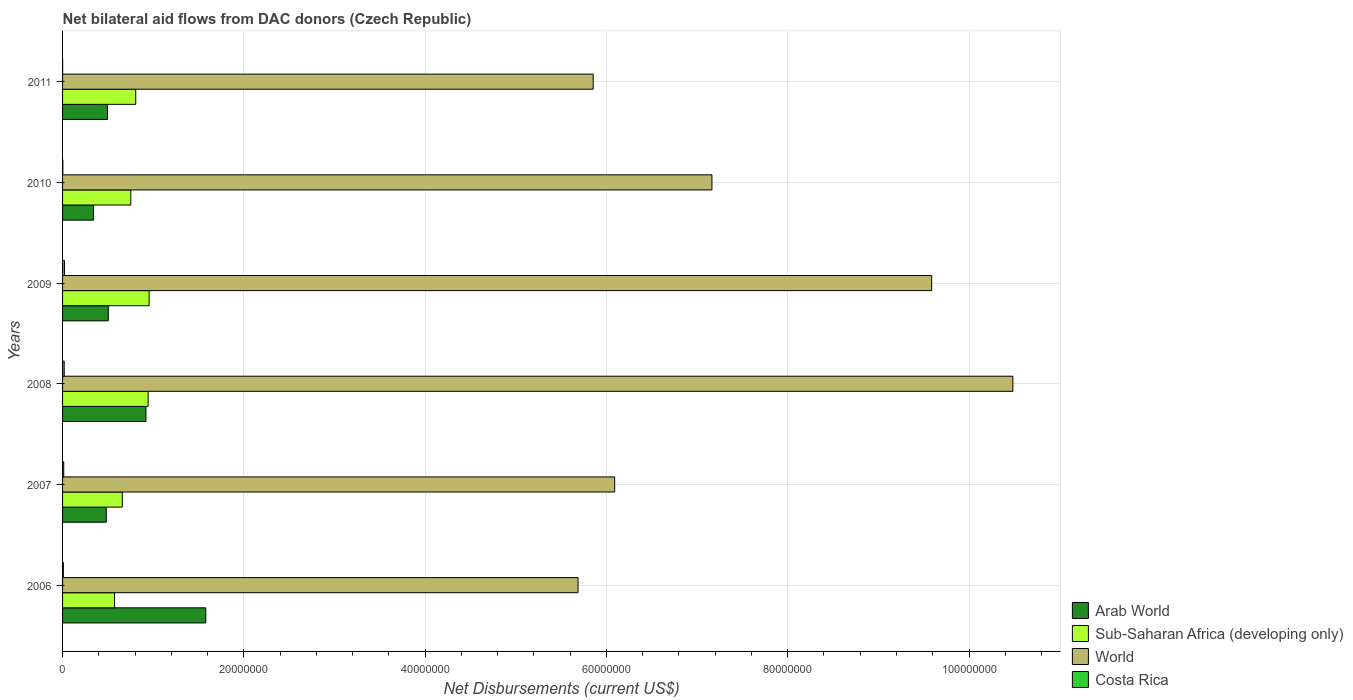How many bars are there on the 1st tick from the bottom?
Provide a short and direct response. 4. What is the label of the 6th group of bars from the top?
Your response must be concise. 2006. In how many cases, is the number of bars for a given year not equal to the number of legend labels?
Give a very brief answer. 0. Across all years, what is the maximum net bilateral aid flows in World?
Give a very brief answer. 1.05e+08. Across all years, what is the minimum net bilateral aid flows in Sub-Saharan Africa (developing only)?
Provide a short and direct response. 5.74e+06. In which year was the net bilateral aid flows in Arab World maximum?
Your response must be concise. 2006. What is the total net bilateral aid flows in Costa Rica in the graph?
Give a very brief answer. 6.50e+05. What is the difference between the net bilateral aid flows in Costa Rica in 2010 and the net bilateral aid flows in Sub-Saharan Africa (developing only) in 2007?
Offer a terse response. -6.56e+06. What is the average net bilateral aid flows in Arab World per year?
Provide a succinct answer. 7.21e+06. In the year 2009, what is the difference between the net bilateral aid flows in Arab World and net bilateral aid flows in Sub-Saharan Africa (developing only)?
Your response must be concise. -4.50e+06. In how many years, is the net bilateral aid flows in Costa Rica greater than 100000000 US$?
Provide a succinct answer. 0. What is the ratio of the net bilateral aid flows in World in 2007 to that in 2008?
Ensure brevity in your answer.  0.58. Is the net bilateral aid flows in Sub-Saharan Africa (developing only) in 2006 less than that in 2007?
Give a very brief answer. Yes. What is the difference between the highest and the lowest net bilateral aid flows in World?
Your answer should be very brief. 4.80e+07. In how many years, is the net bilateral aid flows in Sub-Saharan Africa (developing only) greater than the average net bilateral aid flows in Sub-Saharan Africa (developing only) taken over all years?
Keep it short and to the point. 3. Is the sum of the net bilateral aid flows in World in 2006 and 2011 greater than the maximum net bilateral aid flows in Sub-Saharan Africa (developing only) across all years?
Keep it short and to the point. Yes. What does the 3rd bar from the top in 2006 represents?
Ensure brevity in your answer.  Sub-Saharan Africa (developing only). What does the 3rd bar from the bottom in 2007 represents?
Make the answer very short. World. Is it the case that in every year, the sum of the net bilateral aid flows in Costa Rica and net bilateral aid flows in Sub-Saharan Africa (developing only) is greater than the net bilateral aid flows in Arab World?
Your answer should be compact. No. Are all the bars in the graph horizontal?
Offer a terse response. Yes. How many years are there in the graph?
Your response must be concise. 6. What is the difference between two consecutive major ticks on the X-axis?
Provide a short and direct response. 2.00e+07. Does the graph contain grids?
Your response must be concise. Yes. What is the title of the graph?
Your answer should be very brief. Net bilateral aid flows from DAC donors (Czech Republic). What is the label or title of the X-axis?
Your answer should be very brief. Net Disbursements (current US$). What is the Net Disbursements (current US$) in Arab World in 2006?
Give a very brief answer. 1.58e+07. What is the Net Disbursements (current US$) of Sub-Saharan Africa (developing only) in 2006?
Your response must be concise. 5.74e+06. What is the Net Disbursements (current US$) of World in 2006?
Offer a terse response. 5.69e+07. What is the Net Disbursements (current US$) in Arab World in 2007?
Provide a succinct answer. 4.82e+06. What is the Net Disbursements (current US$) in Sub-Saharan Africa (developing only) in 2007?
Offer a very short reply. 6.59e+06. What is the Net Disbursements (current US$) of World in 2007?
Your response must be concise. 6.09e+07. What is the Net Disbursements (current US$) in Costa Rica in 2007?
Give a very brief answer. 1.30e+05. What is the Net Disbursements (current US$) of Arab World in 2008?
Ensure brevity in your answer.  9.20e+06. What is the Net Disbursements (current US$) of Sub-Saharan Africa (developing only) in 2008?
Give a very brief answer. 9.44e+06. What is the Net Disbursements (current US$) of World in 2008?
Give a very brief answer. 1.05e+08. What is the Net Disbursements (current US$) in Costa Rica in 2008?
Your answer should be very brief. 1.80e+05. What is the Net Disbursements (current US$) of Arab World in 2009?
Ensure brevity in your answer.  5.05e+06. What is the Net Disbursements (current US$) in Sub-Saharan Africa (developing only) in 2009?
Make the answer very short. 9.55e+06. What is the Net Disbursements (current US$) in World in 2009?
Make the answer very short. 9.59e+07. What is the Net Disbursements (current US$) of Costa Rica in 2009?
Provide a succinct answer. 2.10e+05. What is the Net Disbursements (current US$) of Arab World in 2010?
Offer a very short reply. 3.42e+06. What is the Net Disbursements (current US$) in Sub-Saharan Africa (developing only) in 2010?
Make the answer very short. 7.53e+06. What is the Net Disbursements (current US$) of World in 2010?
Make the answer very short. 7.16e+07. What is the Net Disbursements (current US$) of Costa Rica in 2010?
Provide a succinct answer. 3.00e+04. What is the Net Disbursements (current US$) in Arab World in 2011?
Make the answer very short. 4.95e+06. What is the Net Disbursements (current US$) in Sub-Saharan Africa (developing only) in 2011?
Provide a succinct answer. 8.07e+06. What is the Net Disbursements (current US$) in World in 2011?
Ensure brevity in your answer.  5.85e+07. Across all years, what is the maximum Net Disbursements (current US$) in Arab World?
Your answer should be very brief. 1.58e+07. Across all years, what is the maximum Net Disbursements (current US$) of Sub-Saharan Africa (developing only)?
Your answer should be compact. 9.55e+06. Across all years, what is the maximum Net Disbursements (current US$) of World?
Provide a succinct answer. 1.05e+08. Across all years, what is the maximum Net Disbursements (current US$) in Costa Rica?
Your response must be concise. 2.10e+05. Across all years, what is the minimum Net Disbursements (current US$) of Arab World?
Your response must be concise. 3.42e+06. Across all years, what is the minimum Net Disbursements (current US$) of Sub-Saharan Africa (developing only)?
Give a very brief answer. 5.74e+06. Across all years, what is the minimum Net Disbursements (current US$) of World?
Make the answer very short. 5.69e+07. What is the total Net Disbursements (current US$) of Arab World in the graph?
Your response must be concise. 4.32e+07. What is the total Net Disbursements (current US$) of Sub-Saharan Africa (developing only) in the graph?
Your answer should be very brief. 4.69e+07. What is the total Net Disbursements (current US$) in World in the graph?
Ensure brevity in your answer.  4.49e+08. What is the total Net Disbursements (current US$) in Costa Rica in the graph?
Offer a very short reply. 6.50e+05. What is the difference between the Net Disbursements (current US$) of Arab World in 2006 and that in 2007?
Provide a succinct answer. 1.10e+07. What is the difference between the Net Disbursements (current US$) in Sub-Saharan Africa (developing only) in 2006 and that in 2007?
Provide a succinct answer. -8.50e+05. What is the difference between the Net Disbursements (current US$) of World in 2006 and that in 2007?
Your answer should be very brief. -4.04e+06. What is the difference between the Net Disbursements (current US$) of Arab World in 2006 and that in 2008?
Offer a very short reply. 6.60e+06. What is the difference between the Net Disbursements (current US$) of Sub-Saharan Africa (developing only) in 2006 and that in 2008?
Provide a short and direct response. -3.70e+06. What is the difference between the Net Disbursements (current US$) in World in 2006 and that in 2008?
Offer a very short reply. -4.80e+07. What is the difference between the Net Disbursements (current US$) in Arab World in 2006 and that in 2009?
Provide a succinct answer. 1.08e+07. What is the difference between the Net Disbursements (current US$) of Sub-Saharan Africa (developing only) in 2006 and that in 2009?
Ensure brevity in your answer.  -3.81e+06. What is the difference between the Net Disbursements (current US$) of World in 2006 and that in 2009?
Offer a very short reply. -3.90e+07. What is the difference between the Net Disbursements (current US$) of Arab World in 2006 and that in 2010?
Your response must be concise. 1.24e+07. What is the difference between the Net Disbursements (current US$) in Sub-Saharan Africa (developing only) in 2006 and that in 2010?
Provide a short and direct response. -1.79e+06. What is the difference between the Net Disbursements (current US$) of World in 2006 and that in 2010?
Provide a succinct answer. -1.48e+07. What is the difference between the Net Disbursements (current US$) of Costa Rica in 2006 and that in 2010?
Keep it short and to the point. 6.00e+04. What is the difference between the Net Disbursements (current US$) in Arab World in 2006 and that in 2011?
Provide a succinct answer. 1.08e+07. What is the difference between the Net Disbursements (current US$) in Sub-Saharan Africa (developing only) in 2006 and that in 2011?
Give a very brief answer. -2.33e+06. What is the difference between the Net Disbursements (current US$) in World in 2006 and that in 2011?
Provide a succinct answer. -1.67e+06. What is the difference between the Net Disbursements (current US$) in Arab World in 2007 and that in 2008?
Your response must be concise. -4.38e+06. What is the difference between the Net Disbursements (current US$) in Sub-Saharan Africa (developing only) in 2007 and that in 2008?
Provide a succinct answer. -2.85e+06. What is the difference between the Net Disbursements (current US$) in World in 2007 and that in 2008?
Ensure brevity in your answer.  -4.39e+07. What is the difference between the Net Disbursements (current US$) in Sub-Saharan Africa (developing only) in 2007 and that in 2009?
Give a very brief answer. -2.96e+06. What is the difference between the Net Disbursements (current US$) in World in 2007 and that in 2009?
Your answer should be compact. -3.50e+07. What is the difference between the Net Disbursements (current US$) in Arab World in 2007 and that in 2010?
Offer a terse response. 1.40e+06. What is the difference between the Net Disbursements (current US$) in Sub-Saharan Africa (developing only) in 2007 and that in 2010?
Give a very brief answer. -9.40e+05. What is the difference between the Net Disbursements (current US$) of World in 2007 and that in 2010?
Ensure brevity in your answer.  -1.07e+07. What is the difference between the Net Disbursements (current US$) in Sub-Saharan Africa (developing only) in 2007 and that in 2011?
Your answer should be very brief. -1.48e+06. What is the difference between the Net Disbursements (current US$) of World in 2007 and that in 2011?
Provide a short and direct response. 2.37e+06. What is the difference between the Net Disbursements (current US$) of Costa Rica in 2007 and that in 2011?
Keep it short and to the point. 1.20e+05. What is the difference between the Net Disbursements (current US$) in Arab World in 2008 and that in 2009?
Ensure brevity in your answer.  4.15e+06. What is the difference between the Net Disbursements (current US$) of World in 2008 and that in 2009?
Provide a succinct answer. 8.96e+06. What is the difference between the Net Disbursements (current US$) of Arab World in 2008 and that in 2010?
Provide a succinct answer. 5.78e+06. What is the difference between the Net Disbursements (current US$) in Sub-Saharan Africa (developing only) in 2008 and that in 2010?
Give a very brief answer. 1.91e+06. What is the difference between the Net Disbursements (current US$) in World in 2008 and that in 2010?
Give a very brief answer. 3.32e+07. What is the difference between the Net Disbursements (current US$) in Arab World in 2008 and that in 2011?
Give a very brief answer. 4.25e+06. What is the difference between the Net Disbursements (current US$) of Sub-Saharan Africa (developing only) in 2008 and that in 2011?
Give a very brief answer. 1.37e+06. What is the difference between the Net Disbursements (current US$) of World in 2008 and that in 2011?
Provide a succinct answer. 4.63e+07. What is the difference between the Net Disbursements (current US$) of Arab World in 2009 and that in 2010?
Provide a succinct answer. 1.63e+06. What is the difference between the Net Disbursements (current US$) in Sub-Saharan Africa (developing only) in 2009 and that in 2010?
Offer a terse response. 2.02e+06. What is the difference between the Net Disbursements (current US$) in World in 2009 and that in 2010?
Your answer should be compact. 2.42e+07. What is the difference between the Net Disbursements (current US$) in Costa Rica in 2009 and that in 2010?
Offer a very short reply. 1.80e+05. What is the difference between the Net Disbursements (current US$) of Arab World in 2009 and that in 2011?
Offer a very short reply. 1.00e+05. What is the difference between the Net Disbursements (current US$) of Sub-Saharan Africa (developing only) in 2009 and that in 2011?
Provide a short and direct response. 1.48e+06. What is the difference between the Net Disbursements (current US$) of World in 2009 and that in 2011?
Ensure brevity in your answer.  3.73e+07. What is the difference between the Net Disbursements (current US$) in Costa Rica in 2009 and that in 2011?
Keep it short and to the point. 2.00e+05. What is the difference between the Net Disbursements (current US$) of Arab World in 2010 and that in 2011?
Your answer should be compact. -1.53e+06. What is the difference between the Net Disbursements (current US$) of Sub-Saharan Africa (developing only) in 2010 and that in 2011?
Keep it short and to the point. -5.40e+05. What is the difference between the Net Disbursements (current US$) in World in 2010 and that in 2011?
Offer a very short reply. 1.31e+07. What is the difference between the Net Disbursements (current US$) of Costa Rica in 2010 and that in 2011?
Offer a terse response. 2.00e+04. What is the difference between the Net Disbursements (current US$) in Arab World in 2006 and the Net Disbursements (current US$) in Sub-Saharan Africa (developing only) in 2007?
Make the answer very short. 9.21e+06. What is the difference between the Net Disbursements (current US$) in Arab World in 2006 and the Net Disbursements (current US$) in World in 2007?
Make the answer very short. -4.51e+07. What is the difference between the Net Disbursements (current US$) of Arab World in 2006 and the Net Disbursements (current US$) of Costa Rica in 2007?
Provide a succinct answer. 1.57e+07. What is the difference between the Net Disbursements (current US$) of Sub-Saharan Africa (developing only) in 2006 and the Net Disbursements (current US$) of World in 2007?
Provide a succinct answer. -5.52e+07. What is the difference between the Net Disbursements (current US$) of Sub-Saharan Africa (developing only) in 2006 and the Net Disbursements (current US$) of Costa Rica in 2007?
Your response must be concise. 5.61e+06. What is the difference between the Net Disbursements (current US$) in World in 2006 and the Net Disbursements (current US$) in Costa Rica in 2007?
Make the answer very short. 5.67e+07. What is the difference between the Net Disbursements (current US$) of Arab World in 2006 and the Net Disbursements (current US$) of Sub-Saharan Africa (developing only) in 2008?
Your answer should be compact. 6.36e+06. What is the difference between the Net Disbursements (current US$) of Arab World in 2006 and the Net Disbursements (current US$) of World in 2008?
Make the answer very short. -8.90e+07. What is the difference between the Net Disbursements (current US$) of Arab World in 2006 and the Net Disbursements (current US$) of Costa Rica in 2008?
Your answer should be very brief. 1.56e+07. What is the difference between the Net Disbursements (current US$) of Sub-Saharan Africa (developing only) in 2006 and the Net Disbursements (current US$) of World in 2008?
Provide a succinct answer. -9.91e+07. What is the difference between the Net Disbursements (current US$) of Sub-Saharan Africa (developing only) in 2006 and the Net Disbursements (current US$) of Costa Rica in 2008?
Keep it short and to the point. 5.56e+06. What is the difference between the Net Disbursements (current US$) in World in 2006 and the Net Disbursements (current US$) in Costa Rica in 2008?
Keep it short and to the point. 5.67e+07. What is the difference between the Net Disbursements (current US$) in Arab World in 2006 and the Net Disbursements (current US$) in Sub-Saharan Africa (developing only) in 2009?
Make the answer very short. 6.25e+06. What is the difference between the Net Disbursements (current US$) of Arab World in 2006 and the Net Disbursements (current US$) of World in 2009?
Ensure brevity in your answer.  -8.01e+07. What is the difference between the Net Disbursements (current US$) of Arab World in 2006 and the Net Disbursements (current US$) of Costa Rica in 2009?
Make the answer very short. 1.56e+07. What is the difference between the Net Disbursements (current US$) in Sub-Saharan Africa (developing only) in 2006 and the Net Disbursements (current US$) in World in 2009?
Your answer should be compact. -9.01e+07. What is the difference between the Net Disbursements (current US$) in Sub-Saharan Africa (developing only) in 2006 and the Net Disbursements (current US$) in Costa Rica in 2009?
Make the answer very short. 5.53e+06. What is the difference between the Net Disbursements (current US$) in World in 2006 and the Net Disbursements (current US$) in Costa Rica in 2009?
Make the answer very short. 5.67e+07. What is the difference between the Net Disbursements (current US$) in Arab World in 2006 and the Net Disbursements (current US$) in Sub-Saharan Africa (developing only) in 2010?
Make the answer very short. 8.27e+06. What is the difference between the Net Disbursements (current US$) of Arab World in 2006 and the Net Disbursements (current US$) of World in 2010?
Provide a succinct answer. -5.58e+07. What is the difference between the Net Disbursements (current US$) in Arab World in 2006 and the Net Disbursements (current US$) in Costa Rica in 2010?
Your response must be concise. 1.58e+07. What is the difference between the Net Disbursements (current US$) in Sub-Saharan Africa (developing only) in 2006 and the Net Disbursements (current US$) in World in 2010?
Your answer should be compact. -6.59e+07. What is the difference between the Net Disbursements (current US$) of Sub-Saharan Africa (developing only) in 2006 and the Net Disbursements (current US$) of Costa Rica in 2010?
Offer a terse response. 5.71e+06. What is the difference between the Net Disbursements (current US$) in World in 2006 and the Net Disbursements (current US$) in Costa Rica in 2010?
Make the answer very short. 5.68e+07. What is the difference between the Net Disbursements (current US$) in Arab World in 2006 and the Net Disbursements (current US$) in Sub-Saharan Africa (developing only) in 2011?
Give a very brief answer. 7.73e+06. What is the difference between the Net Disbursements (current US$) of Arab World in 2006 and the Net Disbursements (current US$) of World in 2011?
Make the answer very short. -4.27e+07. What is the difference between the Net Disbursements (current US$) in Arab World in 2006 and the Net Disbursements (current US$) in Costa Rica in 2011?
Keep it short and to the point. 1.58e+07. What is the difference between the Net Disbursements (current US$) in Sub-Saharan Africa (developing only) in 2006 and the Net Disbursements (current US$) in World in 2011?
Ensure brevity in your answer.  -5.28e+07. What is the difference between the Net Disbursements (current US$) in Sub-Saharan Africa (developing only) in 2006 and the Net Disbursements (current US$) in Costa Rica in 2011?
Offer a terse response. 5.73e+06. What is the difference between the Net Disbursements (current US$) in World in 2006 and the Net Disbursements (current US$) in Costa Rica in 2011?
Give a very brief answer. 5.69e+07. What is the difference between the Net Disbursements (current US$) of Arab World in 2007 and the Net Disbursements (current US$) of Sub-Saharan Africa (developing only) in 2008?
Make the answer very short. -4.62e+06. What is the difference between the Net Disbursements (current US$) of Arab World in 2007 and the Net Disbursements (current US$) of World in 2008?
Offer a terse response. -1.00e+08. What is the difference between the Net Disbursements (current US$) in Arab World in 2007 and the Net Disbursements (current US$) in Costa Rica in 2008?
Your answer should be compact. 4.64e+06. What is the difference between the Net Disbursements (current US$) in Sub-Saharan Africa (developing only) in 2007 and the Net Disbursements (current US$) in World in 2008?
Offer a very short reply. -9.82e+07. What is the difference between the Net Disbursements (current US$) of Sub-Saharan Africa (developing only) in 2007 and the Net Disbursements (current US$) of Costa Rica in 2008?
Your response must be concise. 6.41e+06. What is the difference between the Net Disbursements (current US$) in World in 2007 and the Net Disbursements (current US$) in Costa Rica in 2008?
Provide a succinct answer. 6.07e+07. What is the difference between the Net Disbursements (current US$) of Arab World in 2007 and the Net Disbursements (current US$) of Sub-Saharan Africa (developing only) in 2009?
Give a very brief answer. -4.73e+06. What is the difference between the Net Disbursements (current US$) of Arab World in 2007 and the Net Disbursements (current US$) of World in 2009?
Ensure brevity in your answer.  -9.11e+07. What is the difference between the Net Disbursements (current US$) in Arab World in 2007 and the Net Disbursements (current US$) in Costa Rica in 2009?
Provide a succinct answer. 4.61e+06. What is the difference between the Net Disbursements (current US$) in Sub-Saharan Africa (developing only) in 2007 and the Net Disbursements (current US$) in World in 2009?
Make the answer very short. -8.93e+07. What is the difference between the Net Disbursements (current US$) in Sub-Saharan Africa (developing only) in 2007 and the Net Disbursements (current US$) in Costa Rica in 2009?
Provide a short and direct response. 6.38e+06. What is the difference between the Net Disbursements (current US$) of World in 2007 and the Net Disbursements (current US$) of Costa Rica in 2009?
Your answer should be compact. 6.07e+07. What is the difference between the Net Disbursements (current US$) of Arab World in 2007 and the Net Disbursements (current US$) of Sub-Saharan Africa (developing only) in 2010?
Offer a very short reply. -2.71e+06. What is the difference between the Net Disbursements (current US$) in Arab World in 2007 and the Net Disbursements (current US$) in World in 2010?
Make the answer very short. -6.68e+07. What is the difference between the Net Disbursements (current US$) of Arab World in 2007 and the Net Disbursements (current US$) of Costa Rica in 2010?
Your answer should be very brief. 4.79e+06. What is the difference between the Net Disbursements (current US$) of Sub-Saharan Africa (developing only) in 2007 and the Net Disbursements (current US$) of World in 2010?
Your answer should be compact. -6.50e+07. What is the difference between the Net Disbursements (current US$) in Sub-Saharan Africa (developing only) in 2007 and the Net Disbursements (current US$) in Costa Rica in 2010?
Ensure brevity in your answer.  6.56e+06. What is the difference between the Net Disbursements (current US$) of World in 2007 and the Net Disbursements (current US$) of Costa Rica in 2010?
Offer a terse response. 6.09e+07. What is the difference between the Net Disbursements (current US$) of Arab World in 2007 and the Net Disbursements (current US$) of Sub-Saharan Africa (developing only) in 2011?
Your answer should be very brief. -3.25e+06. What is the difference between the Net Disbursements (current US$) in Arab World in 2007 and the Net Disbursements (current US$) in World in 2011?
Offer a very short reply. -5.37e+07. What is the difference between the Net Disbursements (current US$) of Arab World in 2007 and the Net Disbursements (current US$) of Costa Rica in 2011?
Make the answer very short. 4.81e+06. What is the difference between the Net Disbursements (current US$) in Sub-Saharan Africa (developing only) in 2007 and the Net Disbursements (current US$) in World in 2011?
Your response must be concise. -5.20e+07. What is the difference between the Net Disbursements (current US$) in Sub-Saharan Africa (developing only) in 2007 and the Net Disbursements (current US$) in Costa Rica in 2011?
Give a very brief answer. 6.58e+06. What is the difference between the Net Disbursements (current US$) in World in 2007 and the Net Disbursements (current US$) in Costa Rica in 2011?
Provide a succinct answer. 6.09e+07. What is the difference between the Net Disbursements (current US$) of Arab World in 2008 and the Net Disbursements (current US$) of Sub-Saharan Africa (developing only) in 2009?
Give a very brief answer. -3.50e+05. What is the difference between the Net Disbursements (current US$) in Arab World in 2008 and the Net Disbursements (current US$) in World in 2009?
Your answer should be compact. -8.67e+07. What is the difference between the Net Disbursements (current US$) in Arab World in 2008 and the Net Disbursements (current US$) in Costa Rica in 2009?
Your response must be concise. 8.99e+06. What is the difference between the Net Disbursements (current US$) of Sub-Saharan Africa (developing only) in 2008 and the Net Disbursements (current US$) of World in 2009?
Your answer should be very brief. -8.64e+07. What is the difference between the Net Disbursements (current US$) in Sub-Saharan Africa (developing only) in 2008 and the Net Disbursements (current US$) in Costa Rica in 2009?
Make the answer very short. 9.23e+06. What is the difference between the Net Disbursements (current US$) in World in 2008 and the Net Disbursements (current US$) in Costa Rica in 2009?
Provide a succinct answer. 1.05e+08. What is the difference between the Net Disbursements (current US$) in Arab World in 2008 and the Net Disbursements (current US$) in Sub-Saharan Africa (developing only) in 2010?
Ensure brevity in your answer.  1.67e+06. What is the difference between the Net Disbursements (current US$) in Arab World in 2008 and the Net Disbursements (current US$) in World in 2010?
Provide a short and direct response. -6.24e+07. What is the difference between the Net Disbursements (current US$) of Arab World in 2008 and the Net Disbursements (current US$) of Costa Rica in 2010?
Ensure brevity in your answer.  9.17e+06. What is the difference between the Net Disbursements (current US$) of Sub-Saharan Africa (developing only) in 2008 and the Net Disbursements (current US$) of World in 2010?
Offer a very short reply. -6.22e+07. What is the difference between the Net Disbursements (current US$) of Sub-Saharan Africa (developing only) in 2008 and the Net Disbursements (current US$) of Costa Rica in 2010?
Your answer should be very brief. 9.41e+06. What is the difference between the Net Disbursements (current US$) of World in 2008 and the Net Disbursements (current US$) of Costa Rica in 2010?
Make the answer very short. 1.05e+08. What is the difference between the Net Disbursements (current US$) in Arab World in 2008 and the Net Disbursements (current US$) in Sub-Saharan Africa (developing only) in 2011?
Make the answer very short. 1.13e+06. What is the difference between the Net Disbursements (current US$) in Arab World in 2008 and the Net Disbursements (current US$) in World in 2011?
Offer a very short reply. -4.93e+07. What is the difference between the Net Disbursements (current US$) in Arab World in 2008 and the Net Disbursements (current US$) in Costa Rica in 2011?
Provide a short and direct response. 9.19e+06. What is the difference between the Net Disbursements (current US$) in Sub-Saharan Africa (developing only) in 2008 and the Net Disbursements (current US$) in World in 2011?
Offer a very short reply. -4.91e+07. What is the difference between the Net Disbursements (current US$) in Sub-Saharan Africa (developing only) in 2008 and the Net Disbursements (current US$) in Costa Rica in 2011?
Your response must be concise. 9.43e+06. What is the difference between the Net Disbursements (current US$) of World in 2008 and the Net Disbursements (current US$) of Costa Rica in 2011?
Provide a succinct answer. 1.05e+08. What is the difference between the Net Disbursements (current US$) in Arab World in 2009 and the Net Disbursements (current US$) in Sub-Saharan Africa (developing only) in 2010?
Offer a very short reply. -2.48e+06. What is the difference between the Net Disbursements (current US$) in Arab World in 2009 and the Net Disbursements (current US$) in World in 2010?
Provide a short and direct response. -6.66e+07. What is the difference between the Net Disbursements (current US$) of Arab World in 2009 and the Net Disbursements (current US$) of Costa Rica in 2010?
Make the answer very short. 5.02e+06. What is the difference between the Net Disbursements (current US$) in Sub-Saharan Africa (developing only) in 2009 and the Net Disbursements (current US$) in World in 2010?
Give a very brief answer. -6.21e+07. What is the difference between the Net Disbursements (current US$) in Sub-Saharan Africa (developing only) in 2009 and the Net Disbursements (current US$) in Costa Rica in 2010?
Your answer should be very brief. 9.52e+06. What is the difference between the Net Disbursements (current US$) in World in 2009 and the Net Disbursements (current US$) in Costa Rica in 2010?
Ensure brevity in your answer.  9.58e+07. What is the difference between the Net Disbursements (current US$) of Arab World in 2009 and the Net Disbursements (current US$) of Sub-Saharan Africa (developing only) in 2011?
Give a very brief answer. -3.02e+06. What is the difference between the Net Disbursements (current US$) in Arab World in 2009 and the Net Disbursements (current US$) in World in 2011?
Provide a short and direct response. -5.35e+07. What is the difference between the Net Disbursements (current US$) of Arab World in 2009 and the Net Disbursements (current US$) of Costa Rica in 2011?
Provide a short and direct response. 5.04e+06. What is the difference between the Net Disbursements (current US$) of Sub-Saharan Africa (developing only) in 2009 and the Net Disbursements (current US$) of World in 2011?
Keep it short and to the point. -4.90e+07. What is the difference between the Net Disbursements (current US$) of Sub-Saharan Africa (developing only) in 2009 and the Net Disbursements (current US$) of Costa Rica in 2011?
Offer a terse response. 9.54e+06. What is the difference between the Net Disbursements (current US$) in World in 2009 and the Net Disbursements (current US$) in Costa Rica in 2011?
Your answer should be very brief. 9.59e+07. What is the difference between the Net Disbursements (current US$) of Arab World in 2010 and the Net Disbursements (current US$) of Sub-Saharan Africa (developing only) in 2011?
Make the answer very short. -4.65e+06. What is the difference between the Net Disbursements (current US$) of Arab World in 2010 and the Net Disbursements (current US$) of World in 2011?
Your response must be concise. -5.51e+07. What is the difference between the Net Disbursements (current US$) of Arab World in 2010 and the Net Disbursements (current US$) of Costa Rica in 2011?
Make the answer very short. 3.41e+06. What is the difference between the Net Disbursements (current US$) of Sub-Saharan Africa (developing only) in 2010 and the Net Disbursements (current US$) of World in 2011?
Ensure brevity in your answer.  -5.10e+07. What is the difference between the Net Disbursements (current US$) of Sub-Saharan Africa (developing only) in 2010 and the Net Disbursements (current US$) of Costa Rica in 2011?
Give a very brief answer. 7.52e+06. What is the difference between the Net Disbursements (current US$) in World in 2010 and the Net Disbursements (current US$) in Costa Rica in 2011?
Your response must be concise. 7.16e+07. What is the average Net Disbursements (current US$) in Arab World per year?
Your response must be concise. 7.21e+06. What is the average Net Disbursements (current US$) in Sub-Saharan Africa (developing only) per year?
Your answer should be compact. 7.82e+06. What is the average Net Disbursements (current US$) in World per year?
Your answer should be compact. 7.48e+07. What is the average Net Disbursements (current US$) of Costa Rica per year?
Offer a very short reply. 1.08e+05. In the year 2006, what is the difference between the Net Disbursements (current US$) of Arab World and Net Disbursements (current US$) of Sub-Saharan Africa (developing only)?
Offer a very short reply. 1.01e+07. In the year 2006, what is the difference between the Net Disbursements (current US$) in Arab World and Net Disbursements (current US$) in World?
Your response must be concise. -4.11e+07. In the year 2006, what is the difference between the Net Disbursements (current US$) of Arab World and Net Disbursements (current US$) of Costa Rica?
Make the answer very short. 1.57e+07. In the year 2006, what is the difference between the Net Disbursements (current US$) in Sub-Saharan Africa (developing only) and Net Disbursements (current US$) in World?
Make the answer very short. -5.11e+07. In the year 2006, what is the difference between the Net Disbursements (current US$) of Sub-Saharan Africa (developing only) and Net Disbursements (current US$) of Costa Rica?
Offer a very short reply. 5.65e+06. In the year 2006, what is the difference between the Net Disbursements (current US$) in World and Net Disbursements (current US$) in Costa Rica?
Your response must be concise. 5.68e+07. In the year 2007, what is the difference between the Net Disbursements (current US$) of Arab World and Net Disbursements (current US$) of Sub-Saharan Africa (developing only)?
Your response must be concise. -1.77e+06. In the year 2007, what is the difference between the Net Disbursements (current US$) of Arab World and Net Disbursements (current US$) of World?
Keep it short and to the point. -5.61e+07. In the year 2007, what is the difference between the Net Disbursements (current US$) of Arab World and Net Disbursements (current US$) of Costa Rica?
Offer a very short reply. 4.69e+06. In the year 2007, what is the difference between the Net Disbursements (current US$) in Sub-Saharan Africa (developing only) and Net Disbursements (current US$) in World?
Offer a very short reply. -5.43e+07. In the year 2007, what is the difference between the Net Disbursements (current US$) of Sub-Saharan Africa (developing only) and Net Disbursements (current US$) of Costa Rica?
Your response must be concise. 6.46e+06. In the year 2007, what is the difference between the Net Disbursements (current US$) of World and Net Disbursements (current US$) of Costa Rica?
Offer a very short reply. 6.08e+07. In the year 2008, what is the difference between the Net Disbursements (current US$) of Arab World and Net Disbursements (current US$) of Sub-Saharan Africa (developing only)?
Your response must be concise. -2.40e+05. In the year 2008, what is the difference between the Net Disbursements (current US$) in Arab World and Net Disbursements (current US$) in World?
Offer a very short reply. -9.56e+07. In the year 2008, what is the difference between the Net Disbursements (current US$) of Arab World and Net Disbursements (current US$) of Costa Rica?
Keep it short and to the point. 9.02e+06. In the year 2008, what is the difference between the Net Disbursements (current US$) of Sub-Saharan Africa (developing only) and Net Disbursements (current US$) of World?
Ensure brevity in your answer.  -9.54e+07. In the year 2008, what is the difference between the Net Disbursements (current US$) of Sub-Saharan Africa (developing only) and Net Disbursements (current US$) of Costa Rica?
Your response must be concise. 9.26e+06. In the year 2008, what is the difference between the Net Disbursements (current US$) in World and Net Disbursements (current US$) in Costa Rica?
Make the answer very short. 1.05e+08. In the year 2009, what is the difference between the Net Disbursements (current US$) of Arab World and Net Disbursements (current US$) of Sub-Saharan Africa (developing only)?
Provide a short and direct response. -4.50e+06. In the year 2009, what is the difference between the Net Disbursements (current US$) in Arab World and Net Disbursements (current US$) in World?
Your response must be concise. -9.08e+07. In the year 2009, what is the difference between the Net Disbursements (current US$) of Arab World and Net Disbursements (current US$) of Costa Rica?
Provide a short and direct response. 4.84e+06. In the year 2009, what is the difference between the Net Disbursements (current US$) in Sub-Saharan Africa (developing only) and Net Disbursements (current US$) in World?
Give a very brief answer. -8.63e+07. In the year 2009, what is the difference between the Net Disbursements (current US$) of Sub-Saharan Africa (developing only) and Net Disbursements (current US$) of Costa Rica?
Give a very brief answer. 9.34e+06. In the year 2009, what is the difference between the Net Disbursements (current US$) in World and Net Disbursements (current US$) in Costa Rica?
Provide a short and direct response. 9.57e+07. In the year 2010, what is the difference between the Net Disbursements (current US$) in Arab World and Net Disbursements (current US$) in Sub-Saharan Africa (developing only)?
Give a very brief answer. -4.11e+06. In the year 2010, what is the difference between the Net Disbursements (current US$) of Arab World and Net Disbursements (current US$) of World?
Your answer should be very brief. -6.82e+07. In the year 2010, what is the difference between the Net Disbursements (current US$) in Arab World and Net Disbursements (current US$) in Costa Rica?
Your answer should be very brief. 3.39e+06. In the year 2010, what is the difference between the Net Disbursements (current US$) of Sub-Saharan Africa (developing only) and Net Disbursements (current US$) of World?
Provide a short and direct response. -6.41e+07. In the year 2010, what is the difference between the Net Disbursements (current US$) of Sub-Saharan Africa (developing only) and Net Disbursements (current US$) of Costa Rica?
Your answer should be very brief. 7.50e+06. In the year 2010, what is the difference between the Net Disbursements (current US$) in World and Net Disbursements (current US$) in Costa Rica?
Give a very brief answer. 7.16e+07. In the year 2011, what is the difference between the Net Disbursements (current US$) in Arab World and Net Disbursements (current US$) in Sub-Saharan Africa (developing only)?
Offer a very short reply. -3.12e+06. In the year 2011, what is the difference between the Net Disbursements (current US$) of Arab World and Net Disbursements (current US$) of World?
Provide a succinct answer. -5.36e+07. In the year 2011, what is the difference between the Net Disbursements (current US$) of Arab World and Net Disbursements (current US$) of Costa Rica?
Keep it short and to the point. 4.94e+06. In the year 2011, what is the difference between the Net Disbursements (current US$) in Sub-Saharan Africa (developing only) and Net Disbursements (current US$) in World?
Provide a short and direct response. -5.05e+07. In the year 2011, what is the difference between the Net Disbursements (current US$) in Sub-Saharan Africa (developing only) and Net Disbursements (current US$) in Costa Rica?
Your answer should be very brief. 8.06e+06. In the year 2011, what is the difference between the Net Disbursements (current US$) of World and Net Disbursements (current US$) of Costa Rica?
Your answer should be compact. 5.85e+07. What is the ratio of the Net Disbursements (current US$) in Arab World in 2006 to that in 2007?
Your answer should be very brief. 3.28. What is the ratio of the Net Disbursements (current US$) in Sub-Saharan Africa (developing only) in 2006 to that in 2007?
Provide a short and direct response. 0.87. What is the ratio of the Net Disbursements (current US$) in World in 2006 to that in 2007?
Give a very brief answer. 0.93. What is the ratio of the Net Disbursements (current US$) of Costa Rica in 2006 to that in 2007?
Your response must be concise. 0.69. What is the ratio of the Net Disbursements (current US$) of Arab World in 2006 to that in 2008?
Offer a terse response. 1.72. What is the ratio of the Net Disbursements (current US$) of Sub-Saharan Africa (developing only) in 2006 to that in 2008?
Your answer should be very brief. 0.61. What is the ratio of the Net Disbursements (current US$) of World in 2006 to that in 2008?
Your answer should be very brief. 0.54. What is the ratio of the Net Disbursements (current US$) of Arab World in 2006 to that in 2009?
Your answer should be very brief. 3.13. What is the ratio of the Net Disbursements (current US$) in Sub-Saharan Africa (developing only) in 2006 to that in 2009?
Your response must be concise. 0.6. What is the ratio of the Net Disbursements (current US$) of World in 2006 to that in 2009?
Keep it short and to the point. 0.59. What is the ratio of the Net Disbursements (current US$) in Costa Rica in 2006 to that in 2009?
Give a very brief answer. 0.43. What is the ratio of the Net Disbursements (current US$) in Arab World in 2006 to that in 2010?
Keep it short and to the point. 4.62. What is the ratio of the Net Disbursements (current US$) in Sub-Saharan Africa (developing only) in 2006 to that in 2010?
Your answer should be very brief. 0.76. What is the ratio of the Net Disbursements (current US$) in World in 2006 to that in 2010?
Your answer should be very brief. 0.79. What is the ratio of the Net Disbursements (current US$) in Arab World in 2006 to that in 2011?
Offer a terse response. 3.19. What is the ratio of the Net Disbursements (current US$) of Sub-Saharan Africa (developing only) in 2006 to that in 2011?
Offer a very short reply. 0.71. What is the ratio of the Net Disbursements (current US$) of World in 2006 to that in 2011?
Provide a short and direct response. 0.97. What is the ratio of the Net Disbursements (current US$) of Arab World in 2007 to that in 2008?
Ensure brevity in your answer.  0.52. What is the ratio of the Net Disbursements (current US$) of Sub-Saharan Africa (developing only) in 2007 to that in 2008?
Make the answer very short. 0.7. What is the ratio of the Net Disbursements (current US$) in World in 2007 to that in 2008?
Your response must be concise. 0.58. What is the ratio of the Net Disbursements (current US$) in Costa Rica in 2007 to that in 2008?
Your answer should be compact. 0.72. What is the ratio of the Net Disbursements (current US$) of Arab World in 2007 to that in 2009?
Keep it short and to the point. 0.95. What is the ratio of the Net Disbursements (current US$) of Sub-Saharan Africa (developing only) in 2007 to that in 2009?
Your response must be concise. 0.69. What is the ratio of the Net Disbursements (current US$) in World in 2007 to that in 2009?
Keep it short and to the point. 0.64. What is the ratio of the Net Disbursements (current US$) in Costa Rica in 2007 to that in 2009?
Provide a short and direct response. 0.62. What is the ratio of the Net Disbursements (current US$) in Arab World in 2007 to that in 2010?
Provide a short and direct response. 1.41. What is the ratio of the Net Disbursements (current US$) in Sub-Saharan Africa (developing only) in 2007 to that in 2010?
Keep it short and to the point. 0.88. What is the ratio of the Net Disbursements (current US$) of World in 2007 to that in 2010?
Offer a terse response. 0.85. What is the ratio of the Net Disbursements (current US$) in Costa Rica in 2007 to that in 2010?
Provide a succinct answer. 4.33. What is the ratio of the Net Disbursements (current US$) of Arab World in 2007 to that in 2011?
Ensure brevity in your answer.  0.97. What is the ratio of the Net Disbursements (current US$) in Sub-Saharan Africa (developing only) in 2007 to that in 2011?
Offer a very short reply. 0.82. What is the ratio of the Net Disbursements (current US$) of World in 2007 to that in 2011?
Provide a succinct answer. 1.04. What is the ratio of the Net Disbursements (current US$) in Costa Rica in 2007 to that in 2011?
Make the answer very short. 13. What is the ratio of the Net Disbursements (current US$) of Arab World in 2008 to that in 2009?
Keep it short and to the point. 1.82. What is the ratio of the Net Disbursements (current US$) of World in 2008 to that in 2009?
Offer a terse response. 1.09. What is the ratio of the Net Disbursements (current US$) of Costa Rica in 2008 to that in 2009?
Provide a succinct answer. 0.86. What is the ratio of the Net Disbursements (current US$) in Arab World in 2008 to that in 2010?
Your answer should be compact. 2.69. What is the ratio of the Net Disbursements (current US$) of Sub-Saharan Africa (developing only) in 2008 to that in 2010?
Your response must be concise. 1.25. What is the ratio of the Net Disbursements (current US$) in World in 2008 to that in 2010?
Make the answer very short. 1.46. What is the ratio of the Net Disbursements (current US$) of Arab World in 2008 to that in 2011?
Ensure brevity in your answer.  1.86. What is the ratio of the Net Disbursements (current US$) of Sub-Saharan Africa (developing only) in 2008 to that in 2011?
Make the answer very short. 1.17. What is the ratio of the Net Disbursements (current US$) in World in 2008 to that in 2011?
Offer a very short reply. 1.79. What is the ratio of the Net Disbursements (current US$) in Costa Rica in 2008 to that in 2011?
Offer a very short reply. 18. What is the ratio of the Net Disbursements (current US$) in Arab World in 2009 to that in 2010?
Provide a short and direct response. 1.48. What is the ratio of the Net Disbursements (current US$) in Sub-Saharan Africa (developing only) in 2009 to that in 2010?
Keep it short and to the point. 1.27. What is the ratio of the Net Disbursements (current US$) of World in 2009 to that in 2010?
Give a very brief answer. 1.34. What is the ratio of the Net Disbursements (current US$) in Arab World in 2009 to that in 2011?
Offer a terse response. 1.02. What is the ratio of the Net Disbursements (current US$) of Sub-Saharan Africa (developing only) in 2009 to that in 2011?
Offer a terse response. 1.18. What is the ratio of the Net Disbursements (current US$) in World in 2009 to that in 2011?
Give a very brief answer. 1.64. What is the ratio of the Net Disbursements (current US$) in Costa Rica in 2009 to that in 2011?
Offer a very short reply. 21. What is the ratio of the Net Disbursements (current US$) in Arab World in 2010 to that in 2011?
Provide a succinct answer. 0.69. What is the ratio of the Net Disbursements (current US$) of Sub-Saharan Africa (developing only) in 2010 to that in 2011?
Your answer should be compact. 0.93. What is the ratio of the Net Disbursements (current US$) in World in 2010 to that in 2011?
Offer a terse response. 1.22. What is the ratio of the Net Disbursements (current US$) in Costa Rica in 2010 to that in 2011?
Keep it short and to the point. 3. What is the difference between the highest and the second highest Net Disbursements (current US$) of Arab World?
Provide a short and direct response. 6.60e+06. What is the difference between the highest and the second highest Net Disbursements (current US$) in Sub-Saharan Africa (developing only)?
Provide a succinct answer. 1.10e+05. What is the difference between the highest and the second highest Net Disbursements (current US$) in World?
Provide a short and direct response. 8.96e+06. What is the difference between the highest and the second highest Net Disbursements (current US$) of Costa Rica?
Offer a terse response. 3.00e+04. What is the difference between the highest and the lowest Net Disbursements (current US$) of Arab World?
Your answer should be very brief. 1.24e+07. What is the difference between the highest and the lowest Net Disbursements (current US$) of Sub-Saharan Africa (developing only)?
Your answer should be compact. 3.81e+06. What is the difference between the highest and the lowest Net Disbursements (current US$) in World?
Make the answer very short. 4.80e+07. What is the difference between the highest and the lowest Net Disbursements (current US$) of Costa Rica?
Give a very brief answer. 2.00e+05. 